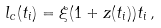Convert formula to latex. <formula><loc_0><loc_0><loc_500><loc_500>l _ { c } ( t _ { i } ) = \xi ( 1 + z ( t _ { i } ) ) t _ { i } \, ,</formula> 